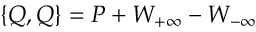<formula> <loc_0><loc_0><loc_500><loc_500>\{ Q , Q \} = P + W _ { + \infty } - W _ { - \infty }</formula> 